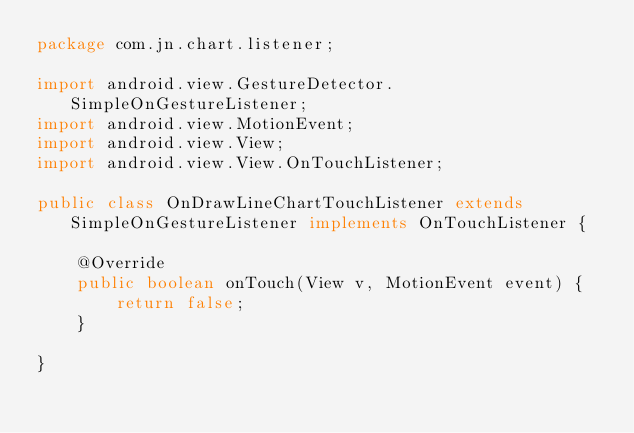<code> <loc_0><loc_0><loc_500><loc_500><_Java_>package com.jn.chart.listener;

import android.view.GestureDetector.SimpleOnGestureListener;
import android.view.MotionEvent;
import android.view.View;
import android.view.View.OnTouchListener;

public class OnDrawLineChartTouchListener extends SimpleOnGestureListener implements OnTouchListener {

	@Override
	public boolean onTouch(View v, MotionEvent event) {
		return false;
	}

}
</code> 